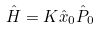<formula> <loc_0><loc_0><loc_500><loc_500>\hat { H } = K \hat { x } _ { 0 } \hat { P } _ { 0 }</formula> 